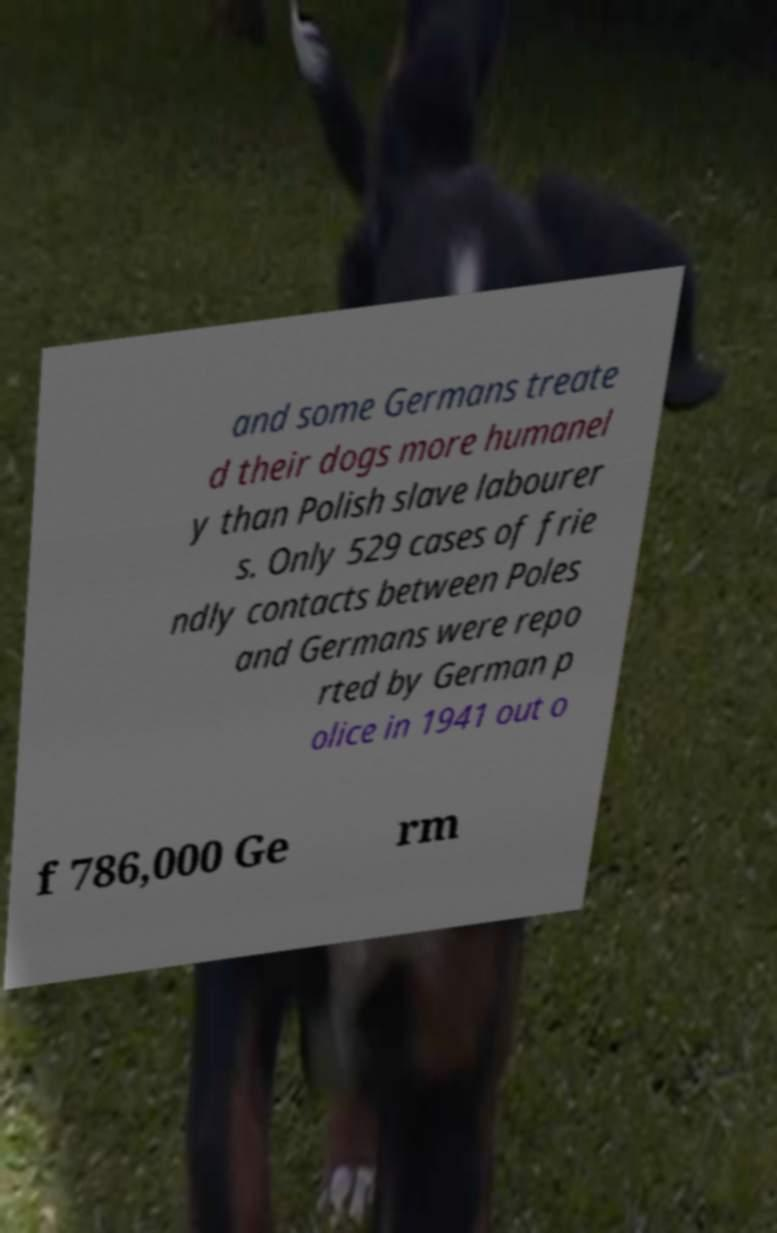Could you assist in decoding the text presented in this image and type it out clearly? and some Germans treate d their dogs more humanel y than Polish slave labourer s. Only 529 cases of frie ndly contacts between Poles and Germans were repo rted by German p olice in 1941 out o f 786,000 Ge rm 